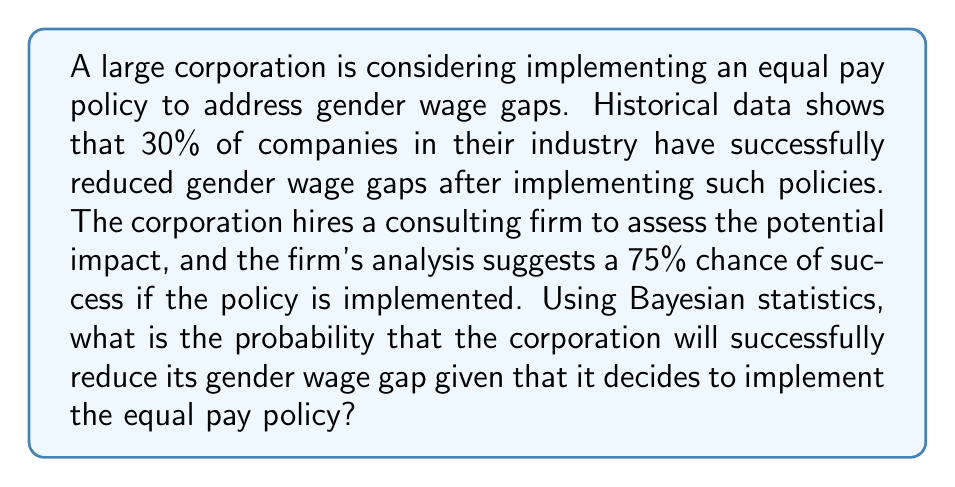Teach me how to tackle this problem. To solve this problem, we'll use Bayes' theorem:

$$ P(A|B) = \frac{P(B|A) \cdot P(A)}{P(B)} $$

Where:
A = Successfully reducing gender wage gap
B = Implementing the equal pay policy

Given:
- P(A) = 0.30 (prior probability of success based on industry data)
- P(B|A) = 0.75 (likelihood of implementing the policy given success, from the consulting firm)

We need to calculate P(B) using the law of total probability:

$$ P(B) = P(B|A) \cdot P(A) + P(B|\neg A) \cdot P(\neg A) $$

We don't have P(B|¬A), but we can assume it's the complement of P(B|A):

P(B|¬A) = 1 - 0.75 = 0.25

And P(¬A) = 1 - P(A) = 1 - 0.30 = 0.70

Now we can calculate P(B):

$$ P(B) = 0.75 \cdot 0.30 + 0.25 \cdot 0.70 = 0.225 + 0.175 = 0.40 $$

Plugging everything into Bayes' theorem:

$$ P(A|B) = \frac{0.75 \cdot 0.30}{0.40} = \frac{0.225}{0.40} = 0.5625 $$

Therefore, the probability of successfully reducing the gender wage gap given that the corporation implements the equal pay policy is 0.5625 or 56.25%.
Answer: 0.5625 or 56.25% 